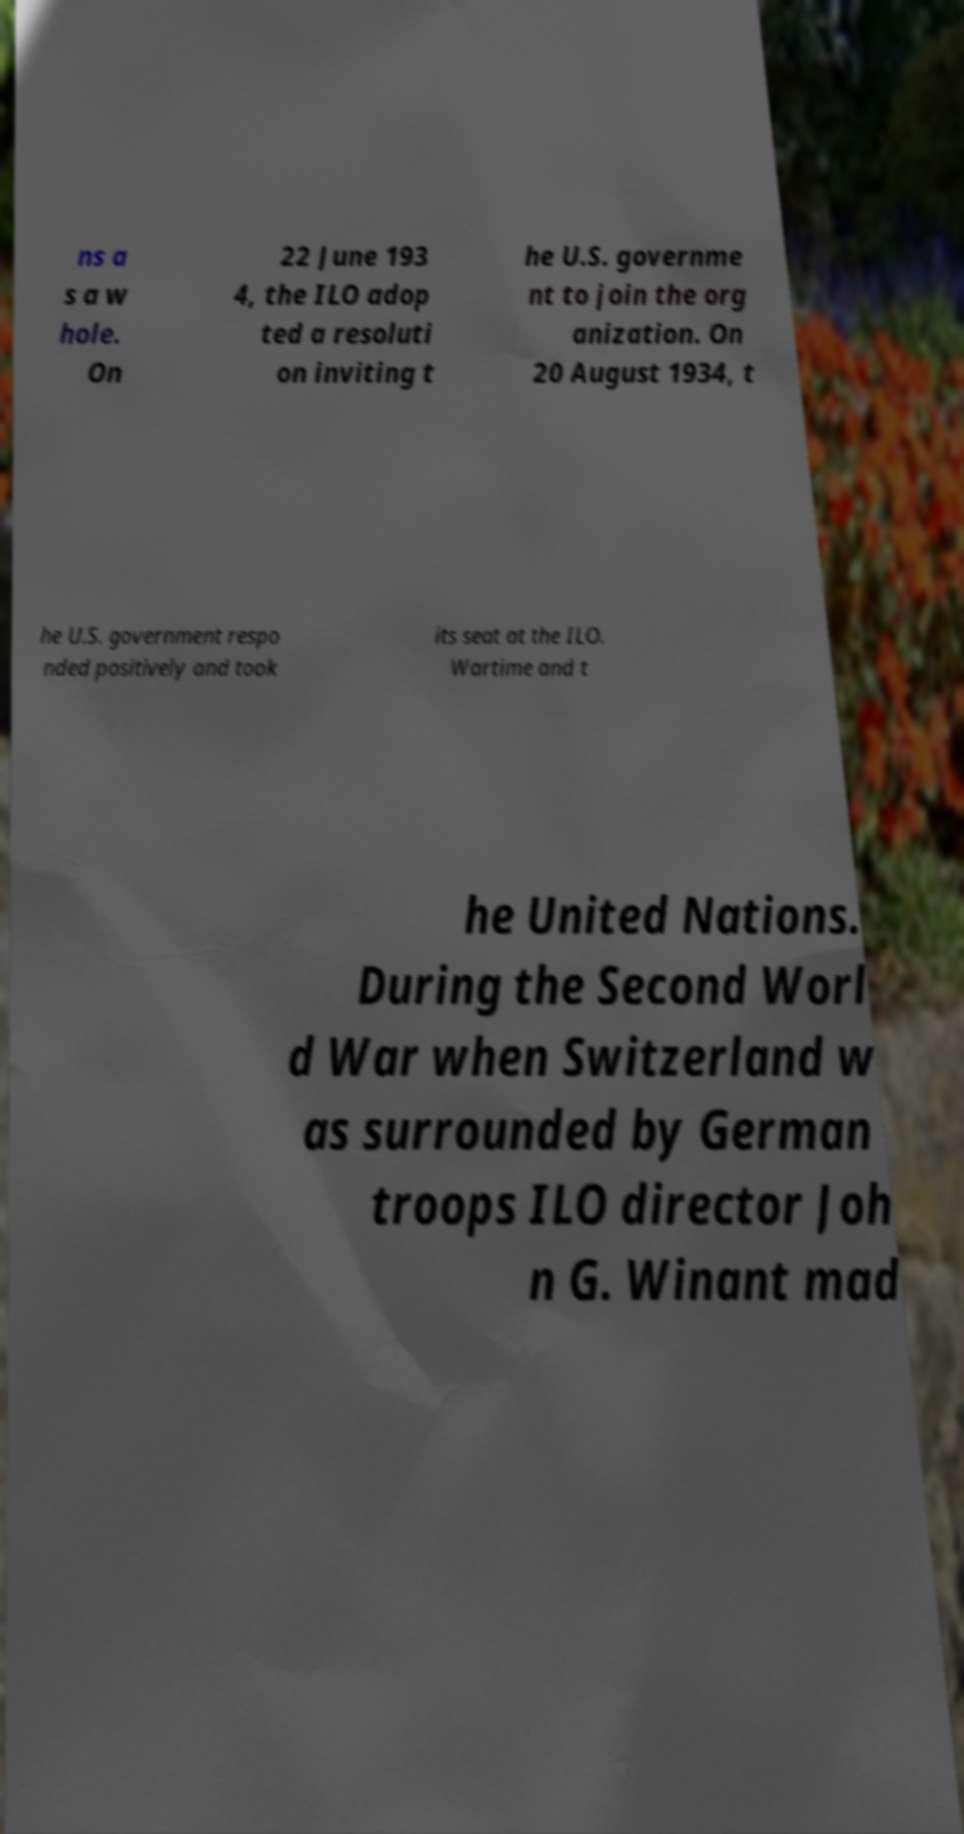Could you assist in decoding the text presented in this image and type it out clearly? ns a s a w hole. On 22 June 193 4, the ILO adop ted a resoluti on inviting t he U.S. governme nt to join the org anization. On 20 August 1934, t he U.S. government respo nded positively and took its seat at the ILO. Wartime and t he United Nations. During the Second Worl d War when Switzerland w as surrounded by German troops ILO director Joh n G. Winant mad 